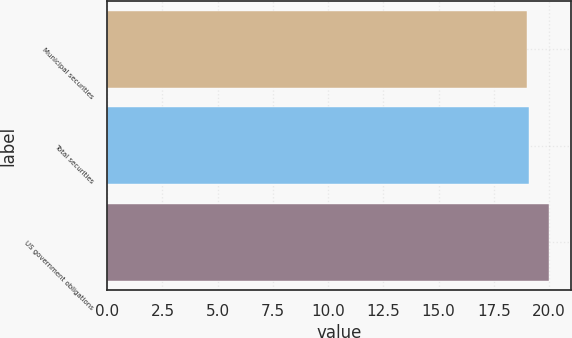Convert chart. <chart><loc_0><loc_0><loc_500><loc_500><bar_chart><fcel>Municipal securities<fcel>Total securities<fcel>US government obligations<nl><fcel>19<fcel>19.1<fcel>20<nl></chart> 